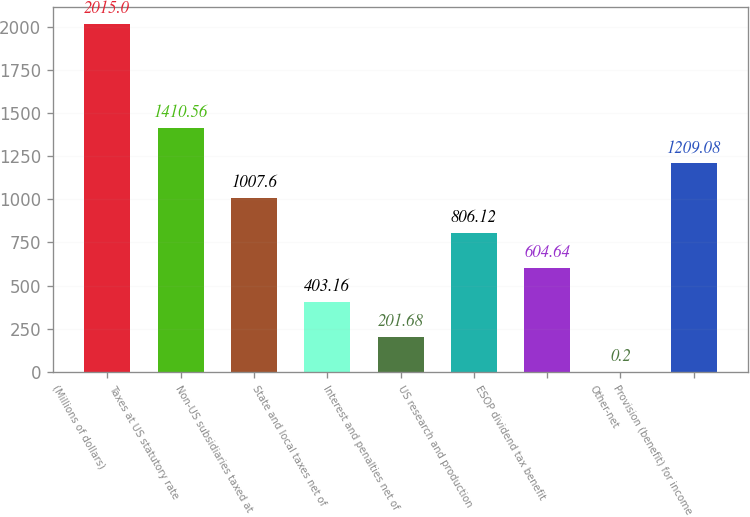Convert chart to OTSL. <chart><loc_0><loc_0><loc_500><loc_500><bar_chart><fcel>(Millions of dollars)<fcel>Taxes at US statutory rate<fcel>Non-US subsidiaries taxed at<fcel>State and local taxes net of<fcel>Interest and penalties net of<fcel>US research and production<fcel>ESOP dividend tax benefit<fcel>Other-net<fcel>Provision (benefit) for income<nl><fcel>2015<fcel>1410.56<fcel>1007.6<fcel>403.16<fcel>201.68<fcel>806.12<fcel>604.64<fcel>0.2<fcel>1209.08<nl></chart> 